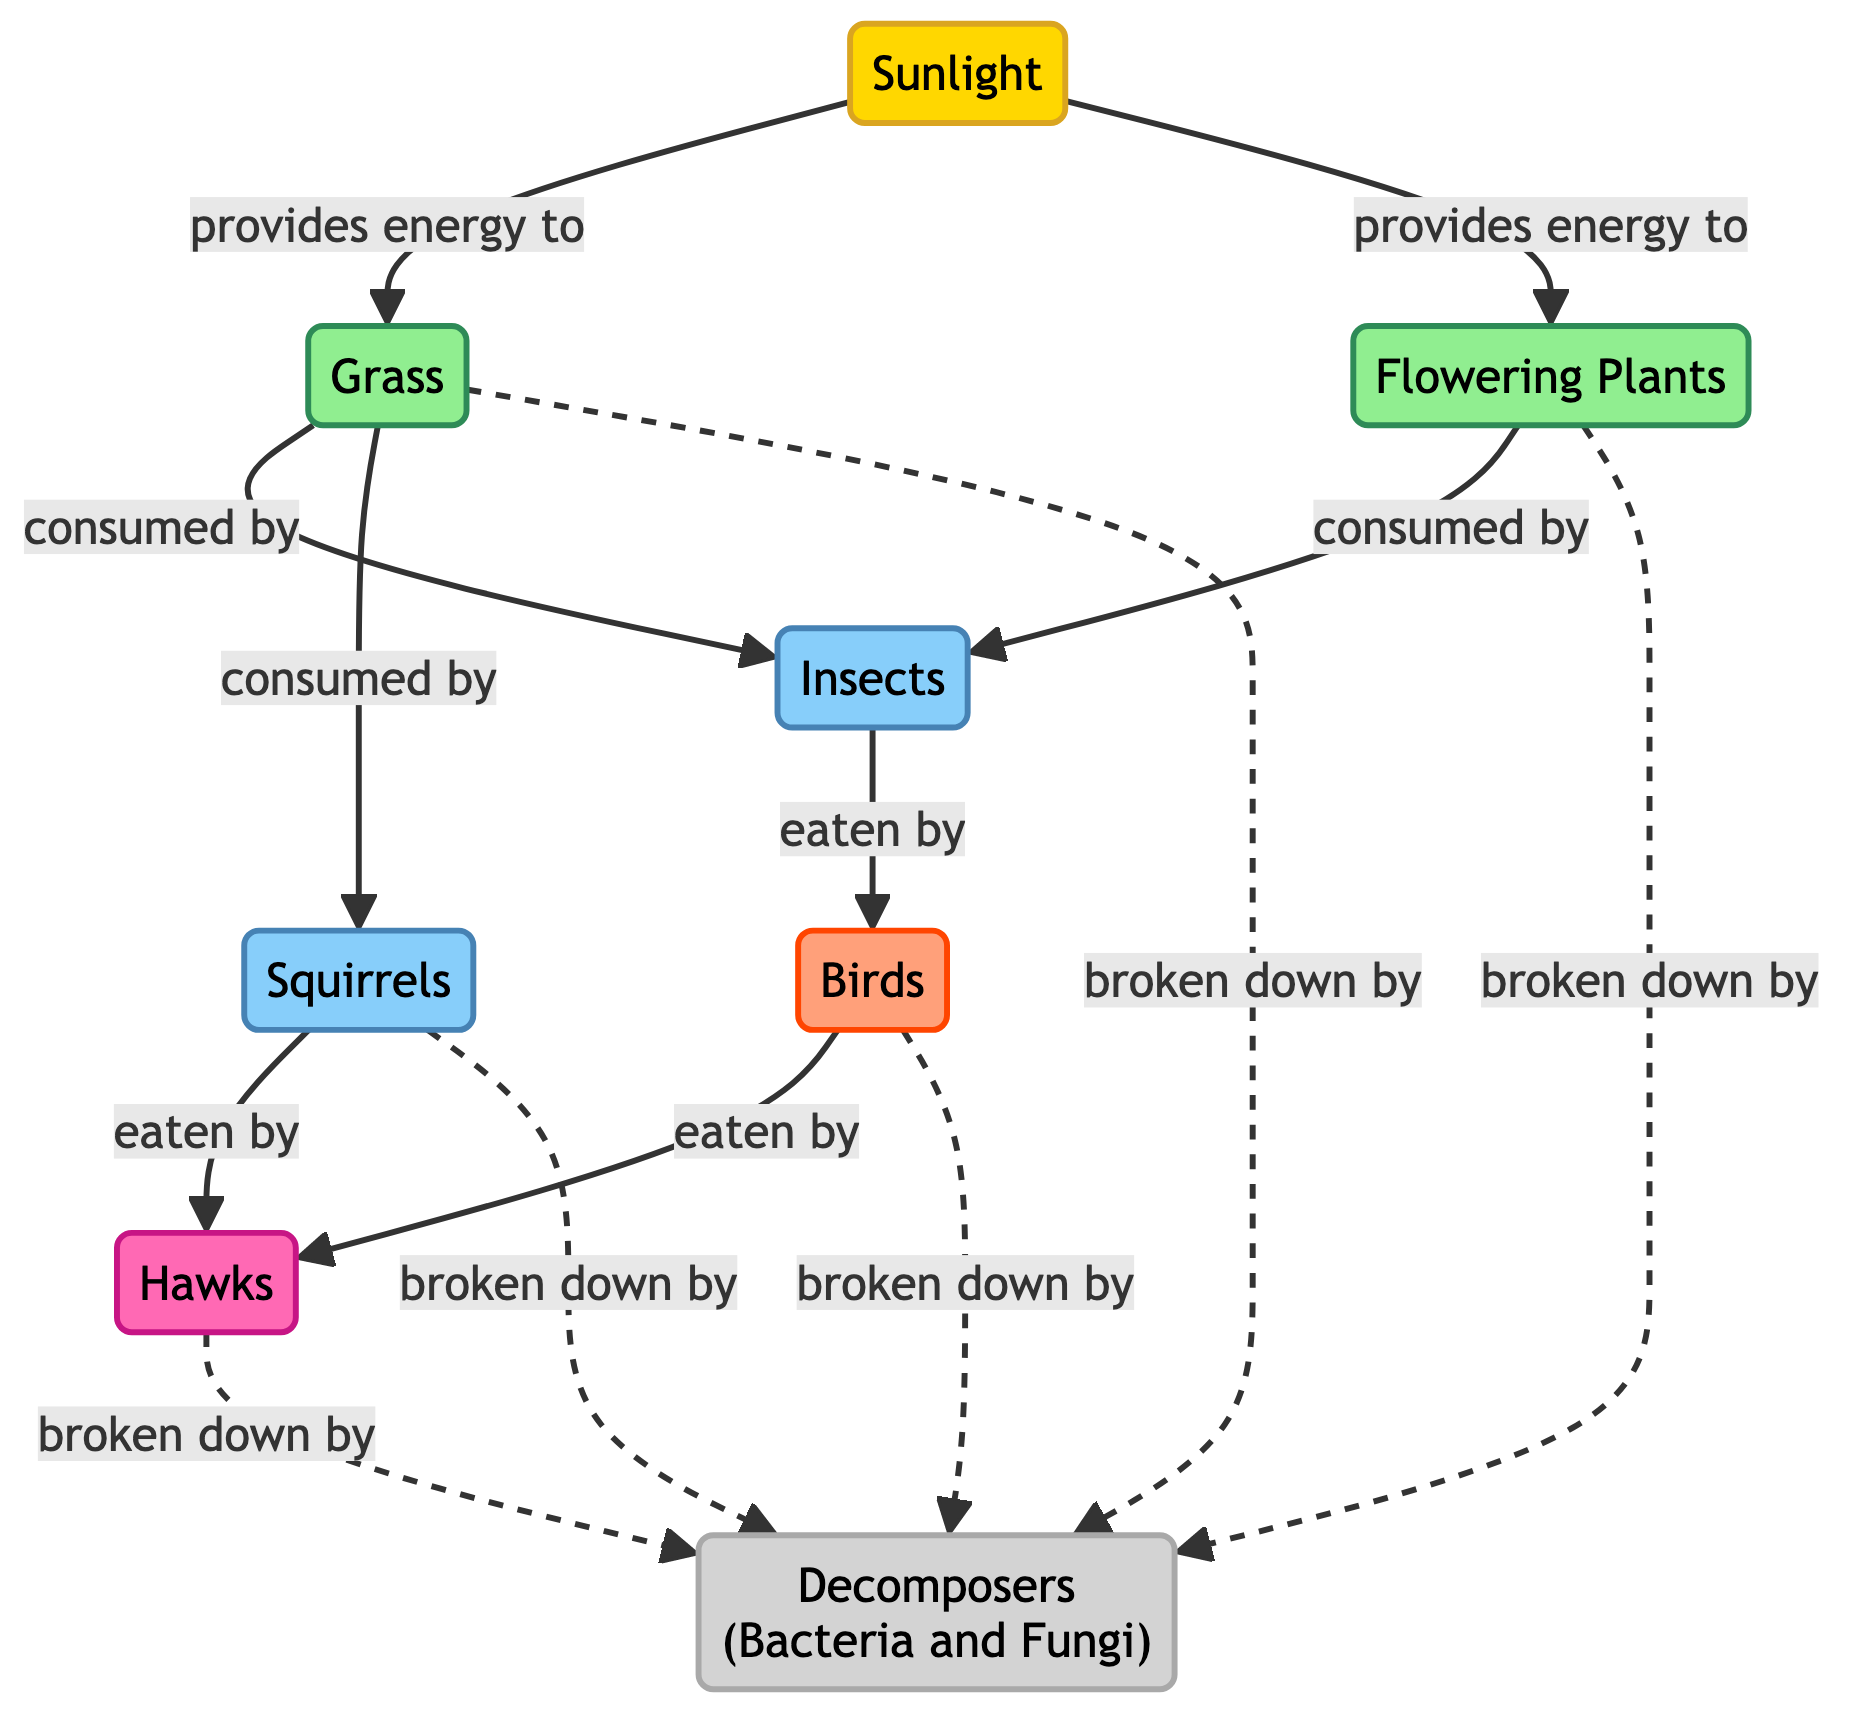What are the two primary producers in this food chain? The diagram identifies grass and flowering plants as the primary producers in the food chain, both receiving energy from sunlight.
Answer: Grass, Flowering Plants How many primary consumers are there in the diagram? The diagram shows two primary consumers, which are insects and squirrels, consuming the producers.
Answer: 2 Which organism consumes both insects and grass? The diagram illustrates that both birds and squirrels consume insects and grass as part of the food chain. However, only squirrels directly consume grass, while birds consume insects.
Answer: Squirrels What organisms are categorized as tertiary consumers? According to the diagram, hawks are the only organisms classified as tertiary consumers, as they consume both birds and squirrels.
Answer: Hawks What is the role of decomposers in this food chain? The diagram indicates that decomposers, such as bacteria and fungi, break down all levels of organic matter, including grass, flowering plants, birds, squirrels, and hawks, returning nutrients to the soil.
Answer: Breakdown Which abiotic factor provides energy to the primary producers? The only abiotic factor mentioned in the diagram is sunlight, which is indicated to provide energy necessary for the growth of the primary producers.
Answer: Sunlight How many types of consumers are present in the food chain? The diagram demonstrates that there are three types of consumers: primary, secondary, and tertiary, with a total of three distinct consumer levels present.
Answer: 3 What type of relationship exists between grass and insects in this diagram? The diagram represents a consumption relationship where insects are shown to consume grass, indicating a direct predator-prey interaction between the two.
Answer: Consumed by What do flowering plants provide to the primary consumers? The diagram clarifies that flowering plants provide sustenance, being consumed by insects, which makes them a food source for the primary consumers.
Answer: Food Source 